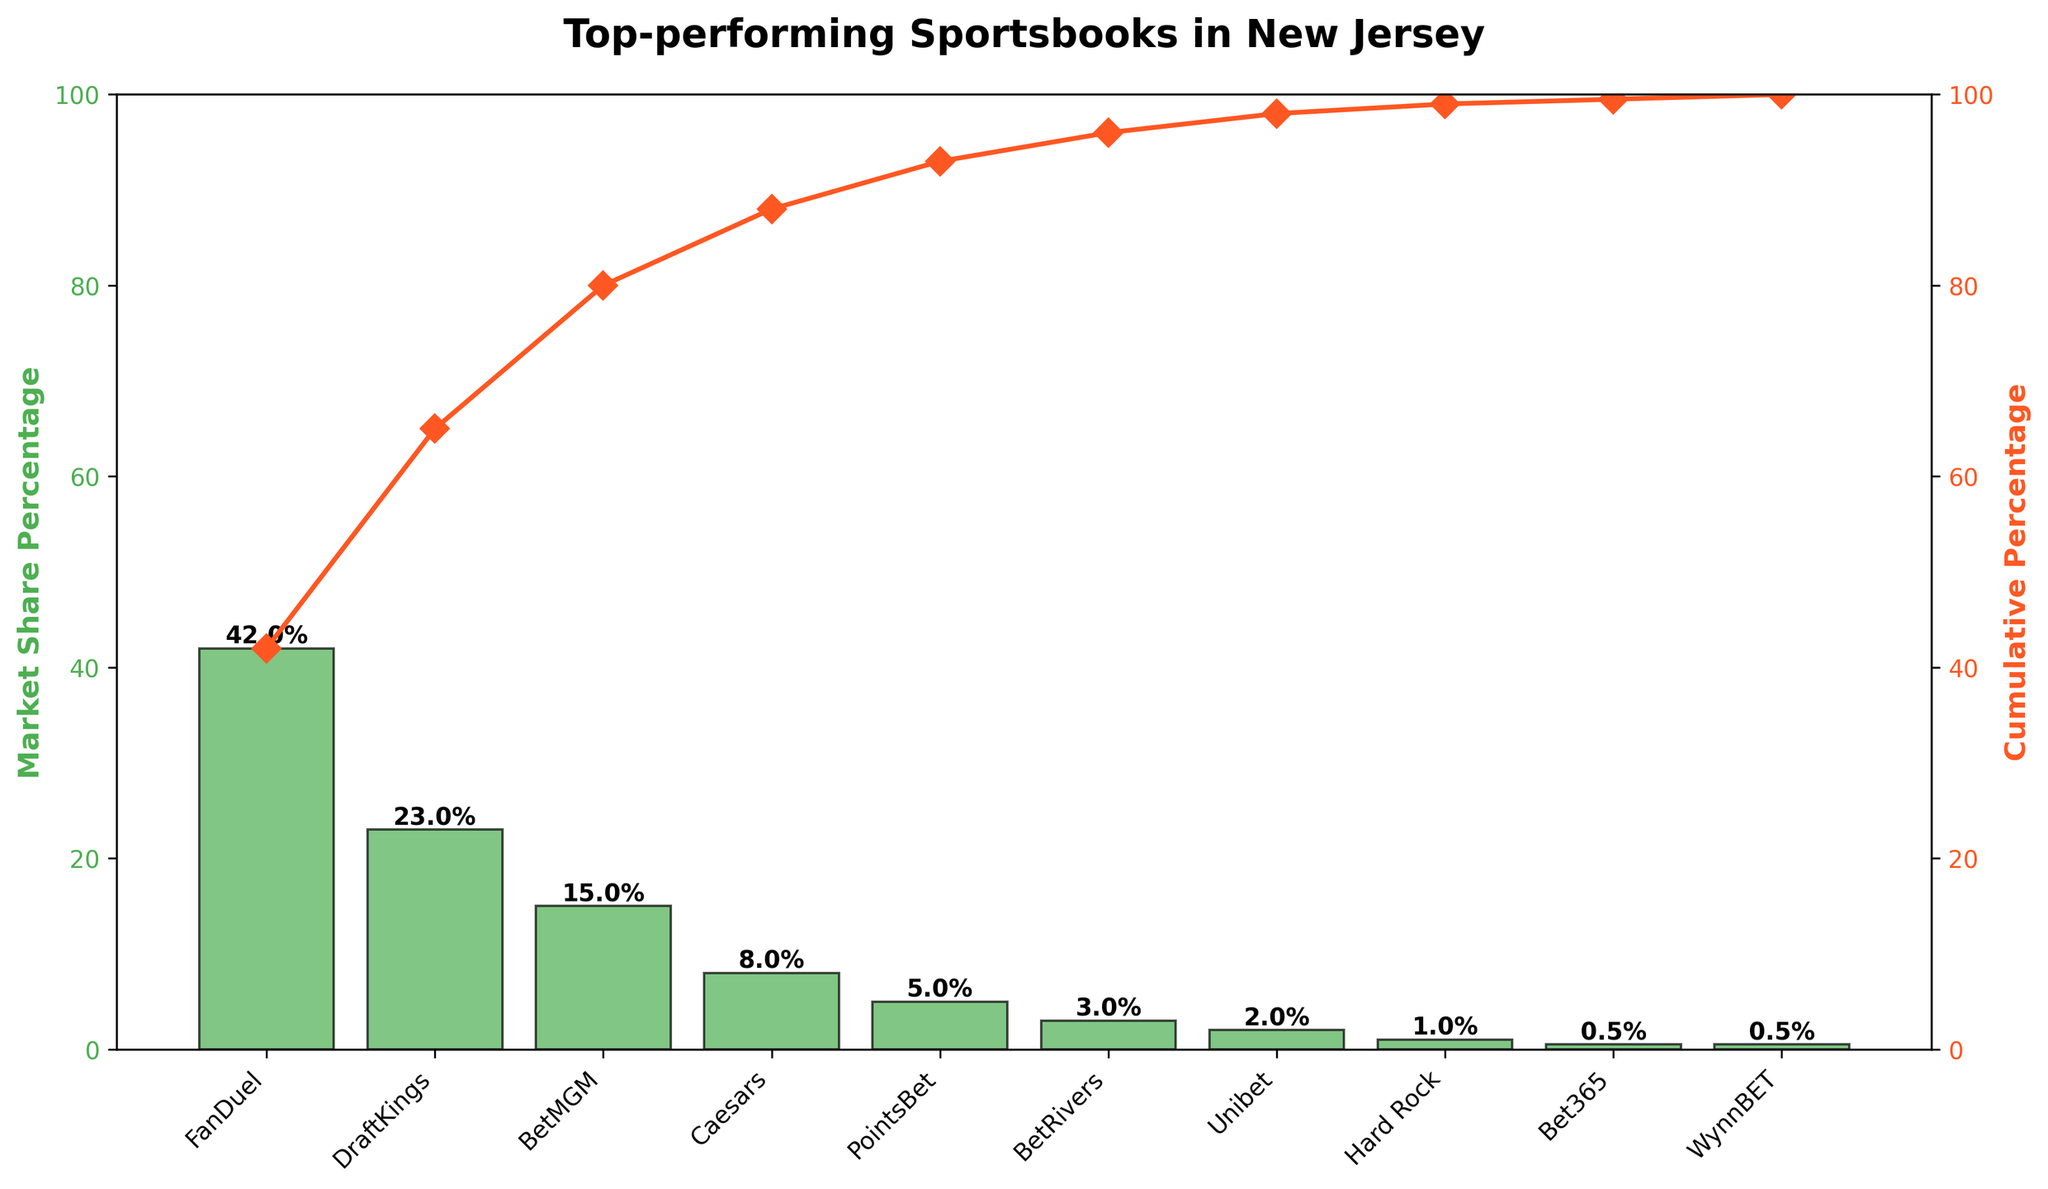What is the title of the figure? The title is displayed at the top of the figure and summarizes the main topic of the chart. It reads "Top-performing Sportsbooks in New Jersey".
Answer: Top-performing Sportsbooks in New Jersey Which sportsbook has the highest market share? The first bar in the chart represents the sportsbook with the highest market share. The label below the bar shows the name "FanDuel" and its market share percentage is 42.
Answer: FanDuel What is the combined market share of DraftKings and BetMGM? To find the combined market share, sum the market share percentages of DraftKings (23) and BetMGM (15). Adding these values gives: 23 + 15 = 38.
Answer: 38% Which sportsbooks have a market share below 5%? The bars with heights below 5% on the y-axis represent these sportsbooks. Reading the corresponding labels from the chart, PointsBet (5), BetRivers (3), Unibet (2), Hard Rock (1), Bet365 (0.5), and WynnBET (0.5) fall into this category.
Answer: PointsBet, BetRivers, Unibet, Hard Rock, Bet365, WynnBET What is the cumulative market share up to BetMGM? The cumulative percentage line indicates the sum of market shares up to each point. For BetMGM (third bar), the value shows cumulative percentages as: FanDuel (42) + DraftKings (23) + BetMGM (15) = 42 + 23 + 15 = 80.
Answer: 80% How many sportsbooks are represented in the chart? Each bar in the chart represents a sportsbook. By counting the bars, there are 10.
Answer: 10 What percentage of the market is captured by the top 3 sportsbooks? The top three sportsbooks by market share are FanDuel (42), DraftKings (23), and BetMGM (15). Summing these values gives 42 + 23 + 15 = 80.
Answer: 80% How does the market share of Caesars compare to that of BetMGM? The heights of the bars and the labels indicate the market share. BetMGM has 15 and Caesars has 8. BetMGM's market share (15) is higher than Caesars (8).
Answer: BetMGM has a higher market share What market share percentage would be needed to reach a cumulative percentage of 90%? The cumulative percentage up to Caesars is 88% (FanDuel 42 + DraftKings 23 + BetMGM 15 + Caesars 8 = 88). To reach 90%, add 2% more. Therefore, the next highest market share is PointsBet with 5%, ensuring cumulative reaches beyond 90%.
Answer: PointsBet Does any sportsbook have the same market share, and if so, which ones? Examining the heights and labels, both Bet365 and WynnBET share the same market share of 0.5%.
Answer: Bet365 and WynnBET 